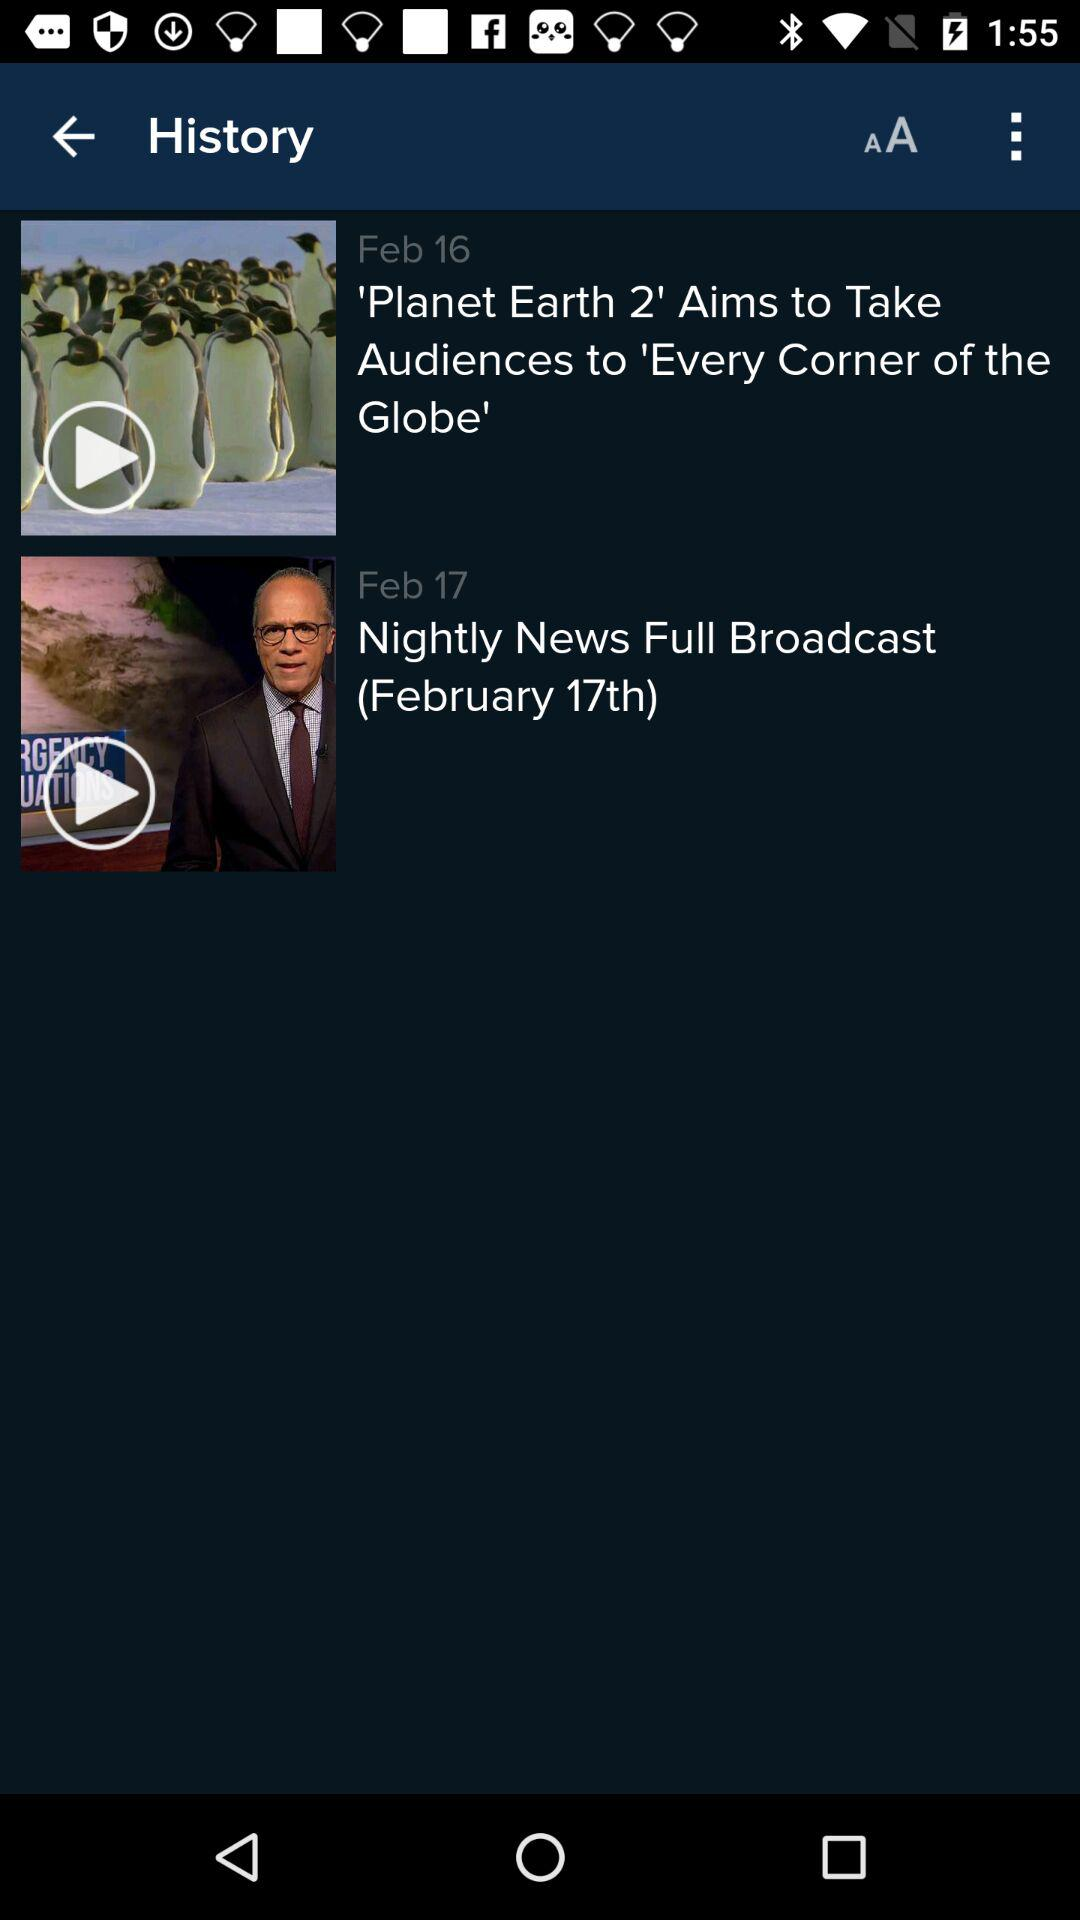How many days apart are the two videos?
Answer the question using a single word or phrase. 1 